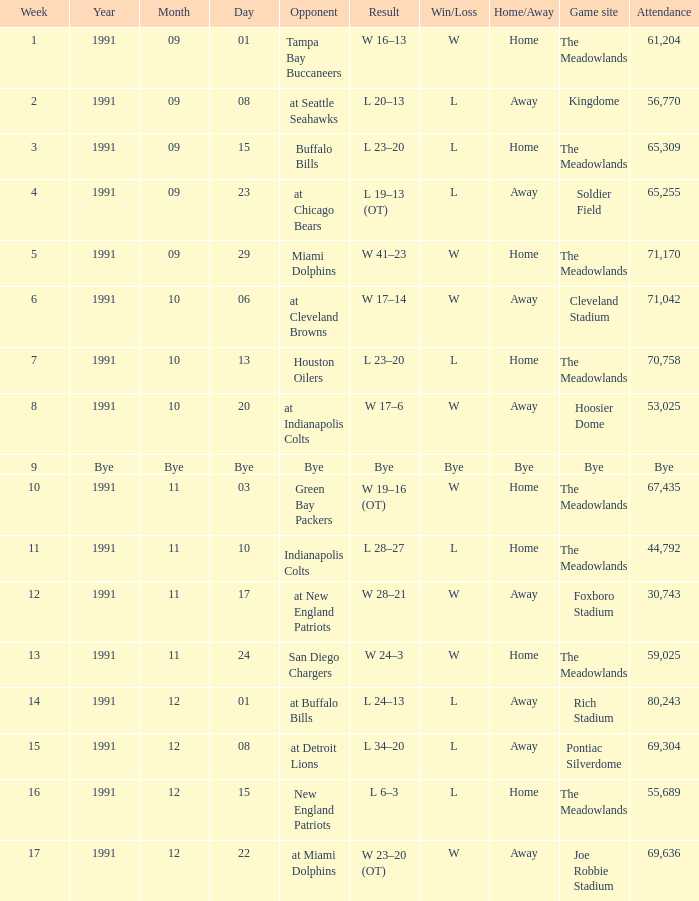What was the Attendance of the Game at Hoosier Dome? 53025.0. 